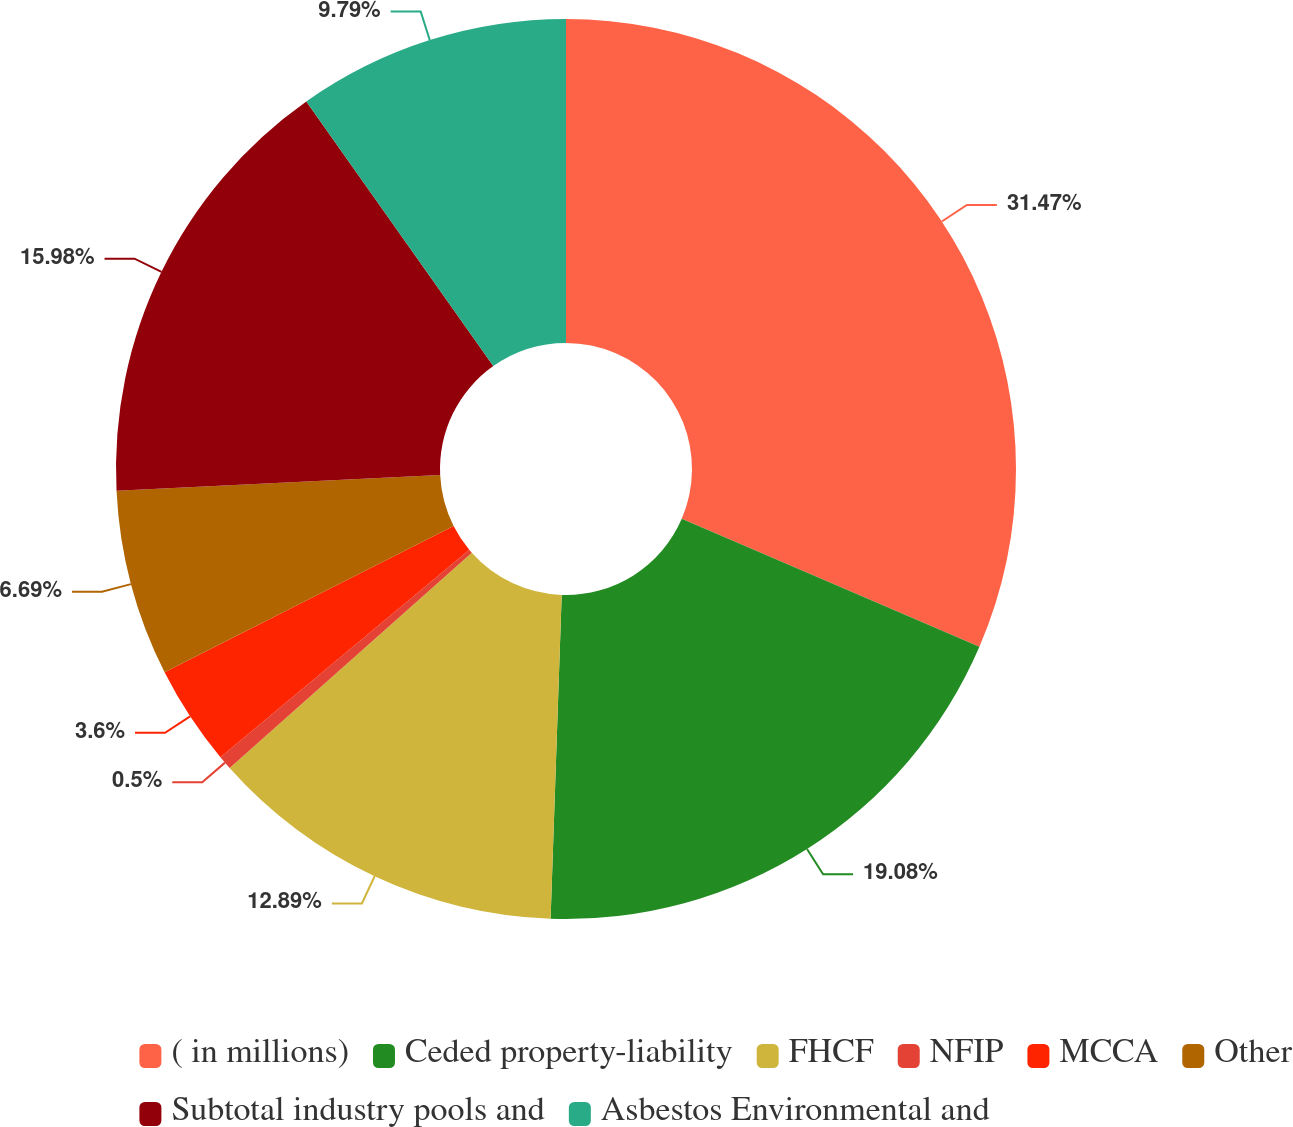<chart> <loc_0><loc_0><loc_500><loc_500><pie_chart><fcel>( in millions)<fcel>Ceded property-liability<fcel>FHCF<fcel>NFIP<fcel>MCCA<fcel>Other<fcel>Subtotal industry pools and<fcel>Asbestos Environmental and<nl><fcel>31.46%<fcel>19.08%<fcel>12.89%<fcel>0.5%<fcel>3.6%<fcel>6.69%<fcel>15.98%<fcel>9.79%<nl></chart> 